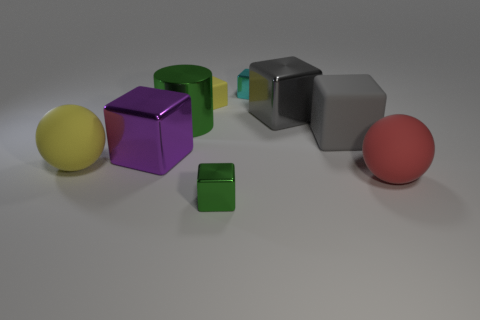Subtract all gray cubes. How many cubes are left? 4 Subtract all green cubes. How many cubes are left? 5 Subtract all blue cubes. Subtract all red spheres. How many cubes are left? 6 Add 1 tiny cyan metal objects. How many objects exist? 10 Subtract all cubes. How many objects are left? 3 Subtract all large red cubes. Subtract all big cubes. How many objects are left? 6 Add 7 gray cubes. How many gray cubes are left? 9 Add 3 large yellow matte things. How many large yellow matte things exist? 4 Subtract 0 red cylinders. How many objects are left? 9 